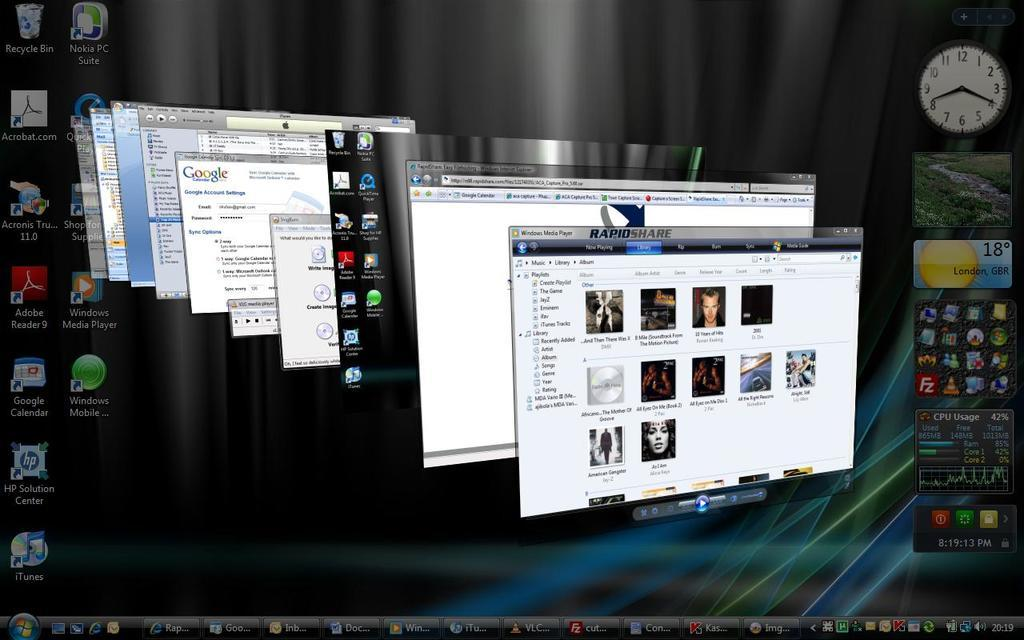<image>
Provide a brief description of the given image. A computer with many open windows has the RapidShare window on top of the others. 